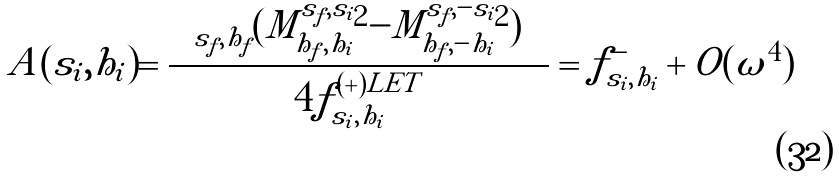Convert formula to latex. <formula><loc_0><loc_0><loc_500><loc_500>A ( s _ { i } , h _ { i } ) = \frac { \sum _ { s _ { f } , h _ { f } } ( | M ^ { s _ { f } , s _ { i } } _ { h _ { f } , h _ { i } } | ^ { 2 } - | M ^ { s _ { f } , - s _ { i } } _ { h _ { f } , - h _ { i } } | ^ { 2 } ) } { 4 f _ { s _ { i } , h _ { i } } ^ { ( + ) L E T } } = f ^ { - } _ { s _ { i } , h _ { i } } + O ( \omega ^ { 4 } )</formula> 